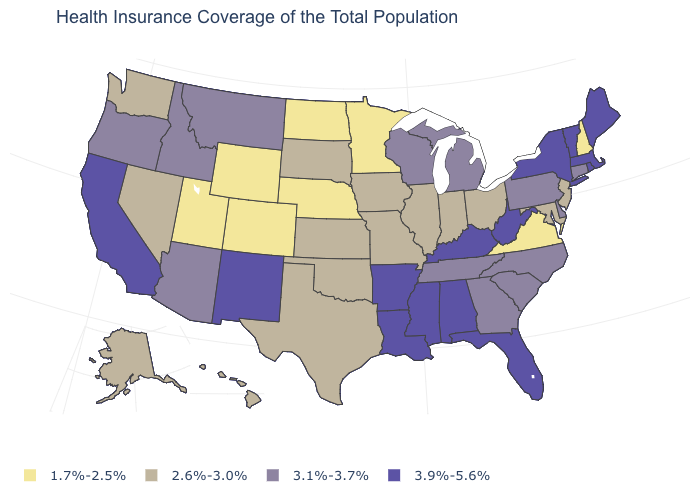What is the value of Massachusetts?
Give a very brief answer. 3.9%-5.6%. What is the value of New York?
Give a very brief answer. 3.9%-5.6%. Does Vermont have the same value as West Virginia?
Be succinct. Yes. What is the value of Maine?
Answer briefly. 3.9%-5.6%. Does Indiana have a higher value than Idaho?
Keep it brief. No. What is the highest value in the Northeast ?
Give a very brief answer. 3.9%-5.6%. Name the states that have a value in the range 2.6%-3.0%?
Quick response, please. Alaska, Hawaii, Illinois, Indiana, Iowa, Kansas, Maryland, Missouri, Nevada, New Jersey, Ohio, Oklahoma, South Dakota, Texas, Washington. Does Mississippi have the highest value in the South?
Answer briefly. Yes. Name the states that have a value in the range 3.9%-5.6%?
Keep it brief. Alabama, Arkansas, California, Florida, Kentucky, Louisiana, Maine, Massachusetts, Mississippi, New Mexico, New York, Rhode Island, Vermont, West Virginia. What is the value of Illinois?
Quick response, please. 2.6%-3.0%. What is the value of West Virginia?
Write a very short answer. 3.9%-5.6%. Does South Carolina have the highest value in the South?
Give a very brief answer. No. Among the states that border North Dakota , does Minnesota have the highest value?
Keep it brief. No. Name the states that have a value in the range 3.9%-5.6%?
Keep it brief. Alabama, Arkansas, California, Florida, Kentucky, Louisiana, Maine, Massachusetts, Mississippi, New Mexico, New York, Rhode Island, Vermont, West Virginia. 